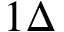Convert formula to latex. <formula><loc_0><loc_0><loc_500><loc_500>1 \Delta</formula> 